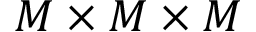Convert formula to latex. <formula><loc_0><loc_0><loc_500><loc_500>M \times M \times M</formula> 